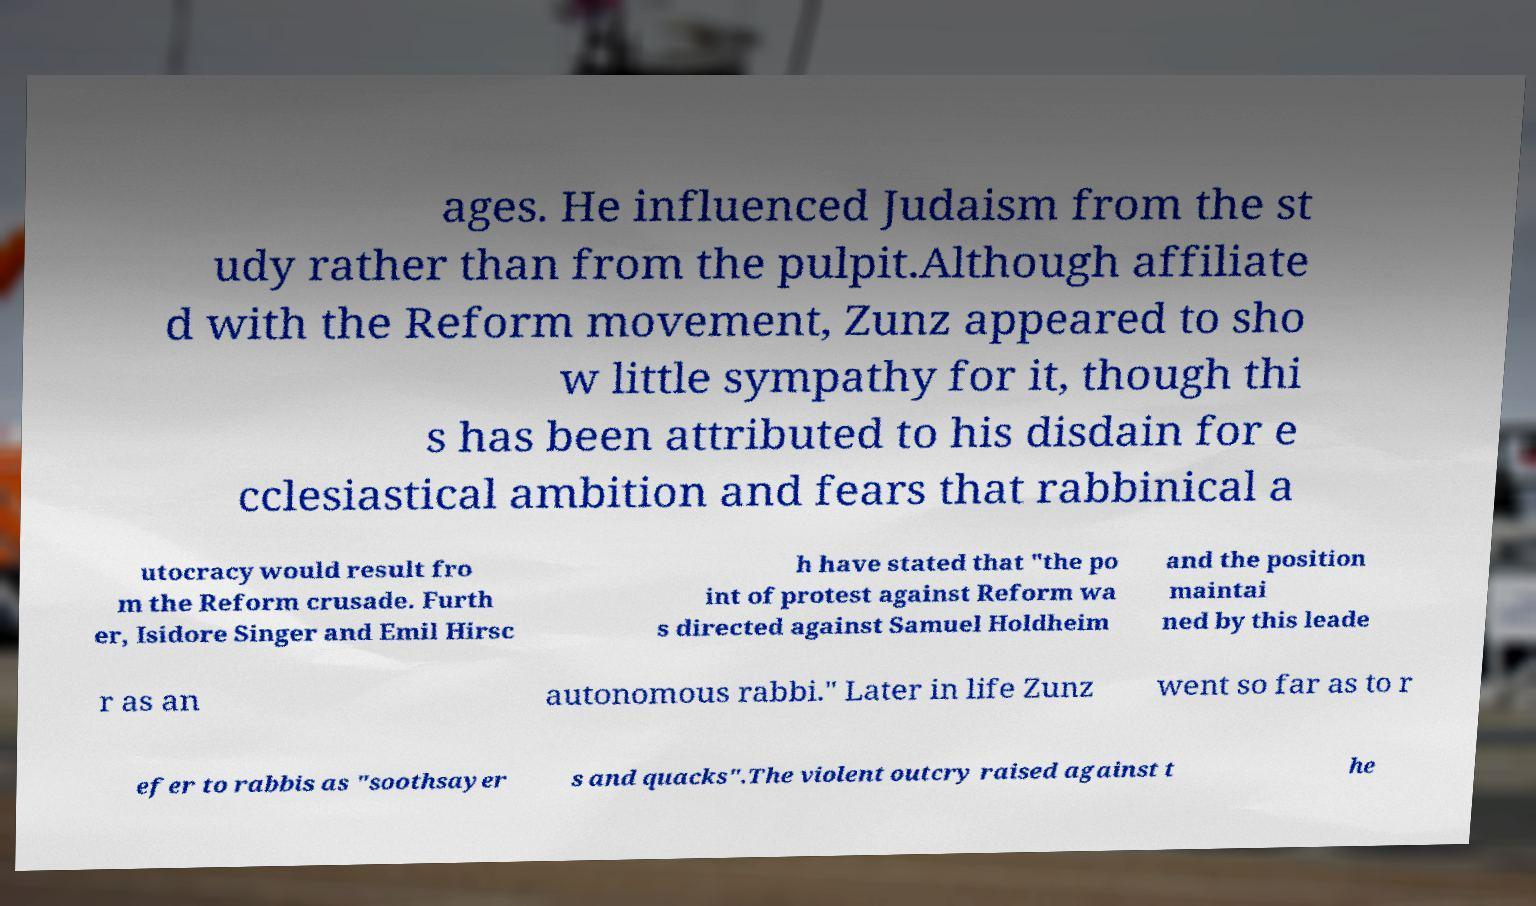Please read and relay the text visible in this image. What does it say? ages. He influenced Judaism from the st udy rather than from the pulpit.Although affiliate d with the Reform movement, Zunz appeared to sho w little sympathy for it, though thi s has been attributed to his disdain for e cclesiastical ambition and fears that rabbinical a utocracy would result fro m the Reform crusade. Furth er, Isidore Singer and Emil Hirsc h have stated that "the po int of protest against Reform wa s directed against Samuel Holdheim and the position maintai ned by this leade r as an autonomous rabbi." Later in life Zunz went so far as to r efer to rabbis as "soothsayer s and quacks".The violent outcry raised against t he 